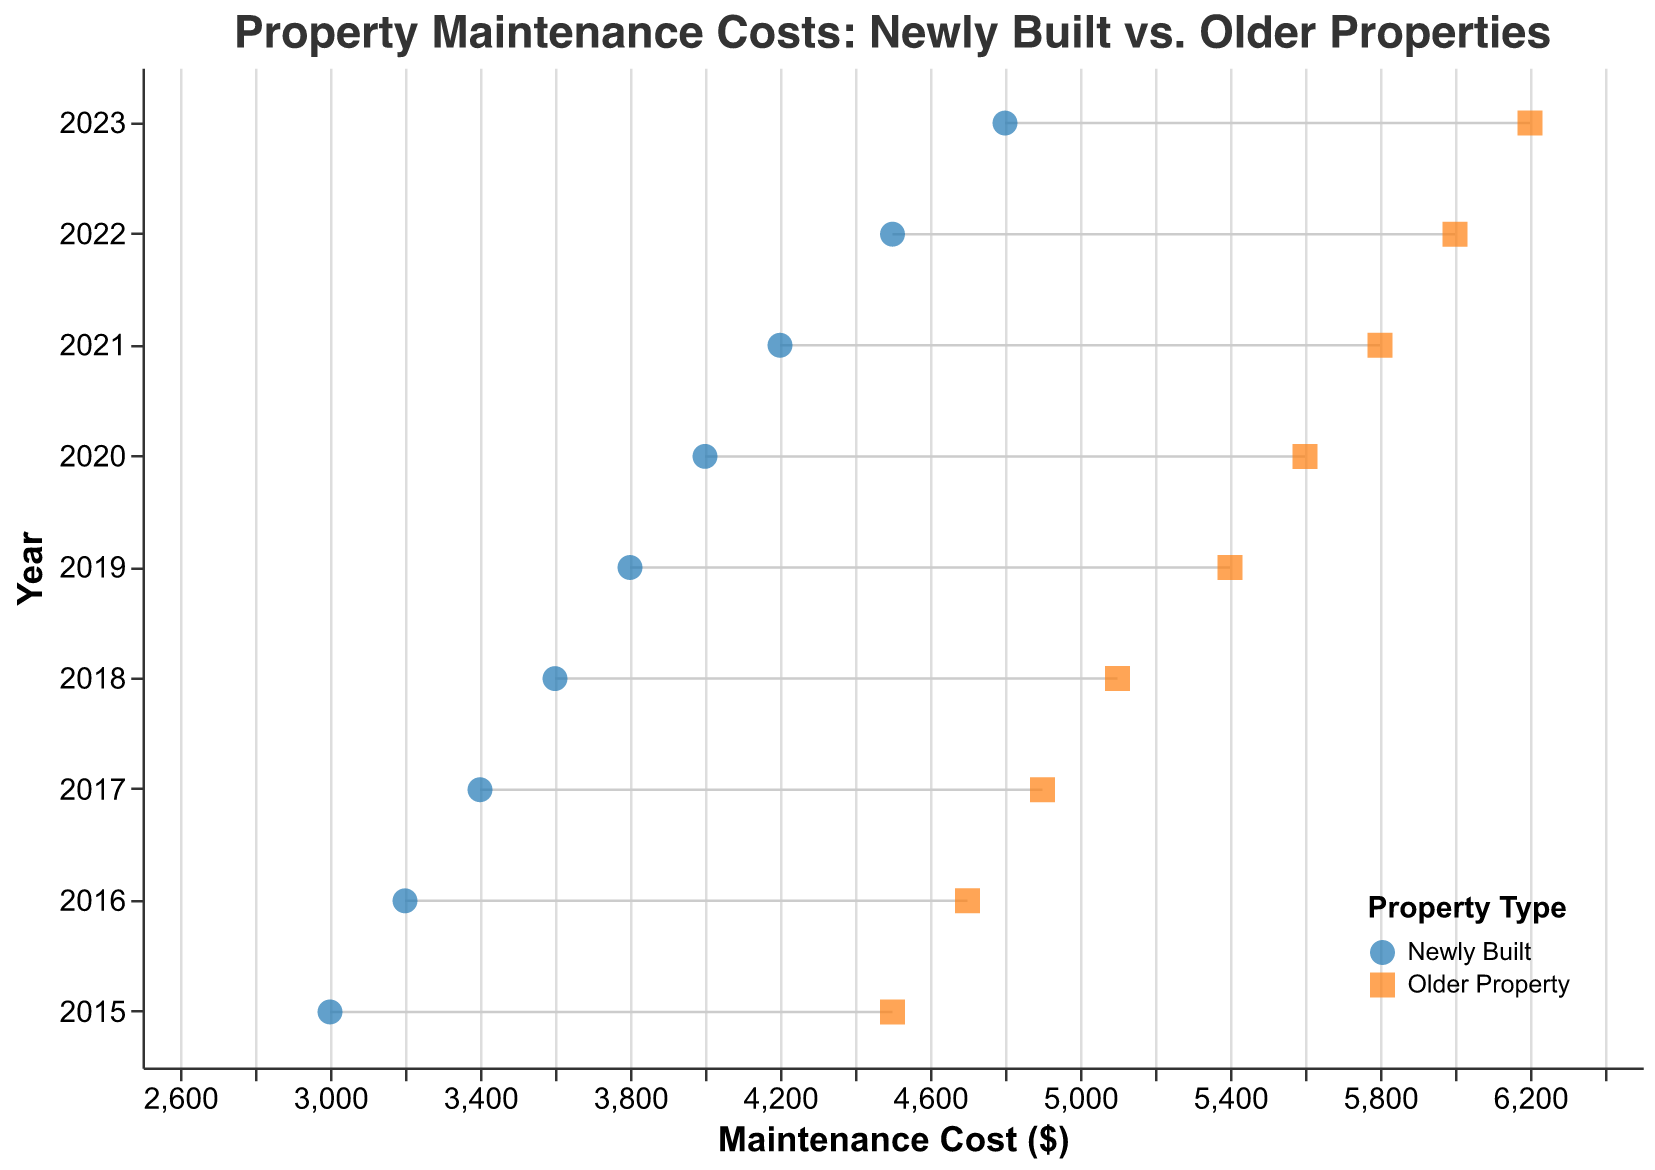What's the title of the plot? The title of the plot is prominently displayed at the top and reads, "Property Maintenance Costs: Newly Built vs. Older Properties".
Answer: Property Maintenance Costs: Newly Built vs. Older Properties Which year has the highest maintenance cost for newly built properties? By examining the x-axis values for the blue circles (newly built properties), the year 2023 shows the highest maintenance cost at $4800.
Answer: 2023 What is the cost difference between newly built and older properties in 2020? For 2020, the maintenance costs for newly built and older properties are $4000 and $5600 respectively. The difference is calculated as $5600 - $4000 = $1600.
Answer: $1600 Which property type generally has higher maintenance costs, newly built or older properties? Comparing the two sets of points along each year, the orange squares (older properties) are consistently to the right, indicating higher maintenance costs than the blue circles (newly built properties).
Answer: Older properties What is the average maintenance cost for newly built properties in the years shown? Summing the costs for each year for newly built properties: $3000 + $3200 + $3400 + $3600 + $3800 + $4000 + $4200 + $4500 + $4800 gives $34500. There are 9 years, so the average is $34500/9 = $3833.33.
Answer: $3833.33 In which year is the maintenance cost difference between newly built and older properties the smallest? By comparing the differences for each year, 2015 has the smallest difference, calculated as $4500 - $3000 = $1500.
Answer: 2015 Over the years, has the maintenance cost for newly built properties increased or decreased? Observing the trend of the blue circles (newly built properties) across the years from 2015 to 2023, the maintenance costs show a steady increase.
Answer: Increased By how much has the maintenance cost for Elmwood Apartments increased from 2015 to 2023? The maintenance costs for Elmwood Apartments in 2015 and 2023 are $4500 and $6200 respectively. The increase is $6200 - $4500 = $1700.
Answer: $1700 Which year shows a maintenance cost of $5100 for older properties? By looking at the x-axis value for the points representing older properties (orange squares), the year with a maintenance cost of $5100 is 2018.
Answer: 2018 